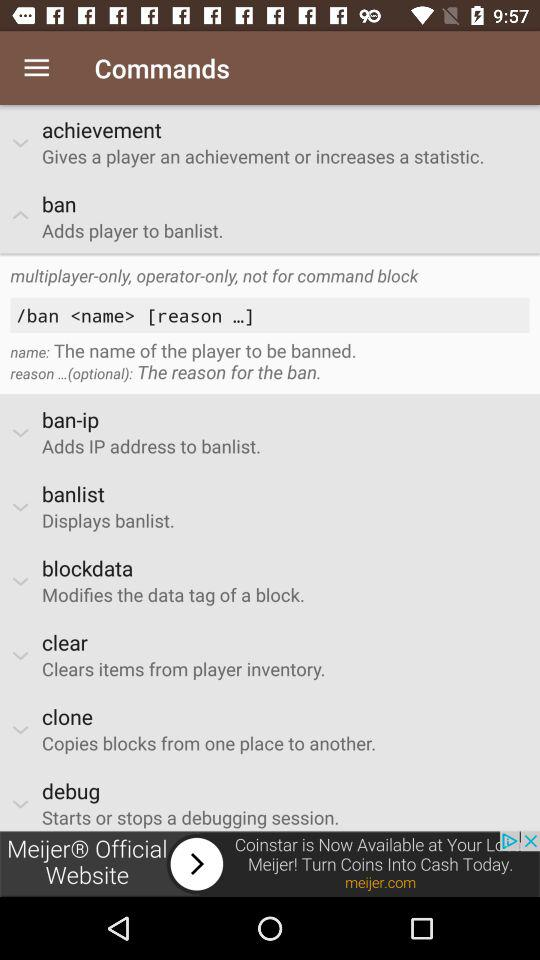What is the command to modify the data tag of a block? The command is blockdata. 